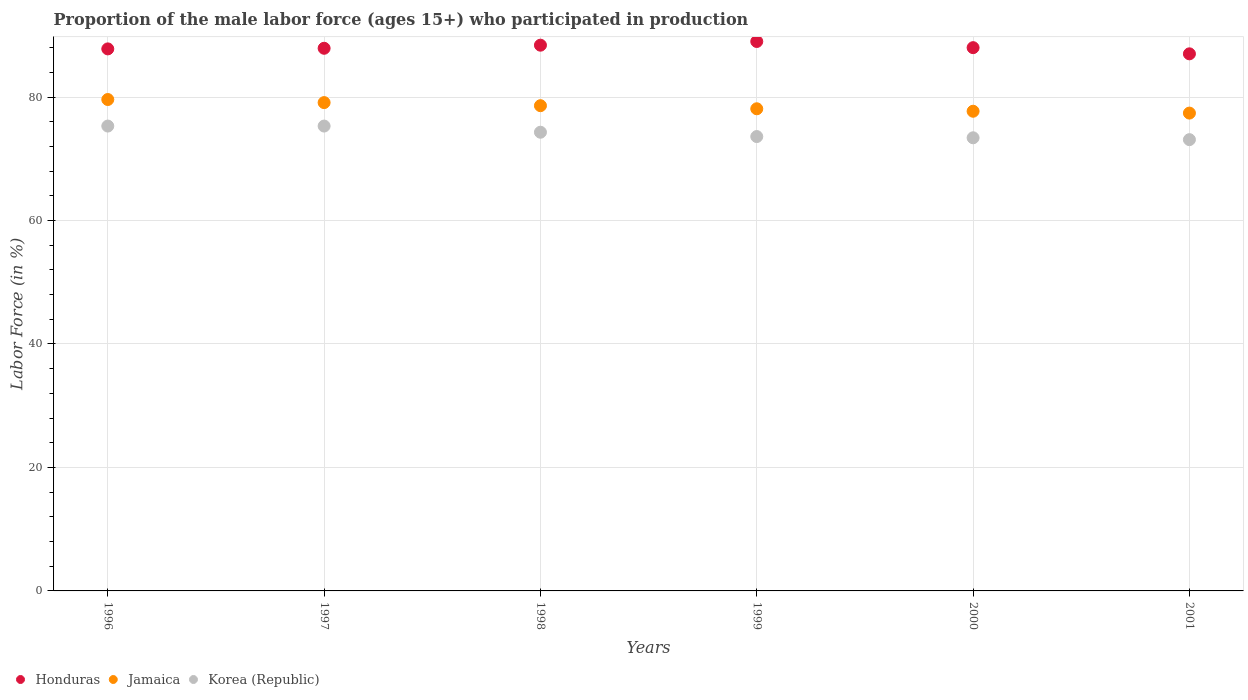How many different coloured dotlines are there?
Your response must be concise. 3. Is the number of dotlines equal to the number of legend labels?
Make the answer very short. Yes. What is the proportion of the male labor force who participated in production in Korea (Republic) in 1999?
Offer a very short reply. 73.6. Across all years, what is the maximum proportion of the male labor force who participated in production in Honduras?
Give a very brief answer. 89. Across all years, what is the minimum proportion of the male labor force who participated in production in Honduras?
Keep it short and to the point. 87. In which year was the proportion of the male labor force who participated in production in Honduras minimum?
Provide a short and direct response. 2001. What is the total proportion of the male labor force who participated in production in Honduras in the graph?
Offer a very short reply. 528.1. What is the difference between the proportion of the male labor force who participated in production in Jamaica in 1998 and that in 2000?
Your answer should be compact. 0.9. What is the difference between the proportion of the male labor force who participated in production in Korea (Republic) in 2001 and the proportion of the male labor force who participated in production in Honduras in 2000?
Your answer should be very brief. -14.9. What is the average proportion of the male labor force who participated in production in Korea (Republic) per year?
Provide a short and direct response. 74.17. In the year 2000, what is the difference between the proportion of the male labor force who participated in production in Jamaica and proportion of the male labor force who participated in production in Korea (Republic)?
Provide a short and direct response. 4.3. In how many years, is the proportion of the male labor force who participated in production in Jamaica greater than 16 %?
Offer a very short reply. 6. What is the ratio of the proportion of the male labor force who participated in production in Jamaica in 1998 to that in 1999?
Keep it short and to the point. 1.01. What is the difference between the highest and the second highest proportion of the male labor force who participated in production in Honduras?
Offer a very short reply. 0.6. What is the difference between the highest and the lowest proportion of the male labor force who participated in production in Jamaica?
Make the answer very short. 2.2. Is the sum of the proportion of the male labor force who participated in production in Honduras in 1997 and 2001 greater than the maximum proportion of the male labor force who participated in production in Korea (Republic) across all years?
Your response must be concise. Yes. Is it the case that in every year, the sum of the proportion of the male labor force who participated in production in Korea (Republic) and proportion of the male labor force who participated in production in Jamaica  is greater than the proportion of the male labor force who participated in production in Honduras?
Provide a short and direct response. Yes. Does the proportion of the male labor force who participated in production in Jamaica monotonically increase over the years?
Offer a very short reply. No. How many years are there in the graph?
Your answer should be very brief. 6. What is the difference between two consecutive major ticks on the Y-axis?
Provide a short and direct response. 20. Does the graph contain any zero values?
Ensure brevity in your answer.  No. Where does the legend appear in the graph?
Your response must be concise. Bottom left. How many legend labels are there?
Make the answer very short. 3. What is the title of the graph?
Your answer should be compact. Proportion of the male labor force (ages 15+) who participated in production. What is the label or title of the X-axis?
Offer a very short reply. Years. What is the label or title of the Y-axis?
Ensure brevity in your answer.  Labor Force (in %). What is the Labor Force (in %) of Honduras in 1996?
Give a very brief answer. 87.8. What is the Labor Force (in %) of Jamaica in 1996?
Ensure brevity in your answer.  79.6. What is the Labor Force (in %) of Korea (Republic) in 1996?
Keep it short and to the point. 75.3. What is the Labor Force (in %) in Honduras in 1997?
Ensure brevity in your answer.  87.9. What is the Labor Force (in %) of Jamaica in 1997?
Ensure brevity in your answer.  79.1. What is the Labor Force (in %) of Korea (Republic) in 1997?
Make the answer very short. 75.3. What is the Labor Force (in %) of Honduras in 1998?
Provide a succinct answer. 88.4. What is the Labor Force (in %) in Jamaica in 1998?
Your answer should be compact. 78.6. What is the Labor Force (in %) in Korea (Republic) in 1998?
Give a very brief answer. 74.3. What is the Labor Force (in %) in Honduras in 1999?
Your answer should be very brief. 89. What is the Labor Force (in %) of Jamaica in 1999?
Ensure brevity in your answer.  78.1. What is the Labor Force (in %) in Korea (Republic) in 1999?
Offer a terse response. 73.6. What is the Labor Force (in %) in Jamaica in 2000?
Provide a short and direct response. 77.7. What is the Labor Force (in %) in Korea (Republic) in 2000?
Your response must be concise. 73.4. What is the Labor Force (in %) of Jamaica in 2001?
Provide a short and direct response. 77.4. What is the Labor Force (in %) in Korea (Republic) in 2001?
Make the answer very short. 73.1. Across all years, what is the maximum Labor Force (in %) in Honduras?
Provide a short and direct response. 89. Across all years, what is the maximum Labor Force (in %) in Jamaica?
Offer a very short reply. 79.6. Across all years, what is the maximum Labor Force (in %) of Korea (Republic)?
Your answer should be very brief. 75.3. Across all years, what is the minimum Labor Force (in %) in Jamaica?
Offer a terse response. 77.4. Across all years, what is the minimum Labor Force (in %) in Korea (Republic)?
Offer a terse response. 73.1. What is the total Labor Force (in %) in Honduras in the graph?
Ensure brevity in your answer.  528.1. What is the total Labor Force (in %) in Jamaica in the graph?
Give a very brief answer. 470.5. What is the total Labor Force (in %) of Korea (Republic) in the graph?
Ensure brevity in your answer.  445. What is the difference between the Labor Force (in %) of Jamaica in 1996 and that in 1998?
Offer a terse response. 1. What is the difference between the Labor Force (in %) of Honduras in 1996 and that in 1999?
Your answer should be compact. -1.2. What is the difference between the Labor Force (in %) in Korea (Republic) in 1996 and that in 2001?
Provide a short and direct response. 2.2. What is the difference between the Labor Force (in %) of Honduras in 1997 and that in 1998?
Provide a succinct answer. -0.5. What is the difference between the Labor Force (in %) in Jamaica in 1997 and that in 1998?
Your response must be concise. 0.5. What is the difference between the Labor Force (in %) in Korea (Republic) in 1997 and that in 1998?
Your response must be concise. 1. What is the difference between the Labor Force (in %) of Jamaica in 1997 and that in 1999?
Ensure brevity in your answer.  1. What is the difference between the Labor Force (in %) of Korea (Republic) in 1997 and that in 1999?
Ensure brevity in your answer.  1.7. What is the difference between the Labor Force (in %) in Honduras in 1997 and that in 2000?
Your answer should be compact. -0.1. What is the difference between the Labor Force (in %) of Jamaica in 1997 and that in 2000?
Your answer should be compact. 1.4. What is the difference between the Labor Force (in %) of Korea (Republic) in 1997 and that in 2000?
Your answer should be compact. 1.9. What is the difference between the Labor Force (in %) of Korea (Republic) in 1997 and that in 2001?
Offer a terse response. 2.2. What is the difference between the Labor Force (in %) of Honduras in 1998 and that in 1999?
Provide a succinct answer. -0.6. What is the difference between the Labor Force (in %) in Korea (Republic) in 1998 and that in 2000?
Give a very brief answer. 0.9. What is the difference between the Labor Force (in %) in Honduras in 1998 and that in 2001?
Your answer should be very brief. 1.4. What is the difference between the Labor Force (in %) of Korea (Republic) in 1998 and that in 2001?
Your answer should be compact. 1.2. What is the difference between the Labor Force (in %) of Honduras in 1999 and that in 2000?
Provide a short and direct response. 1. What is the difference between the Labor Force (in %) of Jamaica in 1999 and that in 2000?
Make the answer very short. 0.4. What is the difference between the Labor Force (in %) of Honduras in 1999 and that in 2001?
Your response must be concise. 2. What is the difference between the Labor Force (in %) in Jamaica in 1999 and that in 2001?
Give a very brief answer. 0.7. What is the difference between the Labor Force (in %) of Korea (Republic) in 1999 and that in 2001?
Provide a short and direct response. 0.5. What is the difference between the Labor Force (in %) in Honduras in 2000 and that in 2001?
Your response must be concise. 1. What is the difference between the Labor Force (in %) in Jamaica in 2000 and that in 2001?
Your answer should be compact. 0.3. What is the difference between the Labor Force (in %) of Korea (Republic) in 2000 and that in 2001?
Keep it short and to the point. 0.3. What is the difference between the Labor Force (in %) in Jamaica in 1996 and the Labor Force (in %) in Korea (Republic) in 1997?
Your response must be concise. 4.3. What is the difference between the Labor Force (in %) of Jamaica in 1996 and the Labor Force (in %) of Korea (Republic) in 1998?
Provide a succinct answer. 5.3. What is the difference between the Labor Force (in %) in Honduras in 1996 and the Labor Force (in %) in Jamaica in 2000?
Keep it short and to the point. 10.1. What is the difference between the Labor Force (in %) of Jamaica in 1996 and the Labor Force (in %) of Korea (Republic) in 2000?
Offer a very short reply. 6.2. What is the difference between the Labor Force (in %) in Honduras in 1997 and the Labor Force (in %) in Jamaica in 1999?
Your answer should be compact. 9.8. What is the difference between the Labor Force (in %) of Jamaica in 1997 and the Labor Force (in %) of Korea (Republic) in 1999?
Your answer should be compact. 5.5. What is the difference between the Labor Force (in %) of Honduras in 1997 and the Labor Force (in %) of Korea (Republic) in 2000?
Offer a terse response. 14.5. What is the difference between the Labor Force (in %) of Jamaica in 1997 and the Labor Force (in %) of Korea (Republic) in 2001?
Offer a terse response. 6. What is the difference between the Labor Force (in %) of Honduras in 1998 and the Labor Force (in %) of Jamaica in 1999?
Your answer should be very brief. 10.3. What is the difference between the Labor Force (in %) in Honduras in 1998 and the Labor Force (in %) in Korea (Republic) in 1999?
Ensure brevity in your answer.  14.8. What is the difference between the Labor Force (in %) of Jamaica in 1998 and the Labor Force (in %) of Korea (Republic) in 1999?
Your answer should be compact. 5. What is the difference between the Labor Force (in %) in Honduras in 1998 and the Labor Force (in %) in Jamaica in 2000?
Your answer should be compact. 10.7. What is the difference between the Labor Force (in %) of Honduras in 1999 and the Labor Force (in %) of Jamaica in 2001?
Give a very brief answer. 11.6. What is the difference between the Labor Force (in %) in Jamaica in 1999 and the Labor Force (in %) in Korea (Republic) in 2001?
Your answer should be very brief. 5. What is the difference between the Labor Force (in %) in Honduras in 2000 and the Labor Force (in %) in Jamaica in 2001?
Offer a terse response. 10.6. What is the difference between the Labor Force (in %) of Honduras in 2000 and the Labor Force (in %) of Korea (Republic) in 2001?
Offer a very short reply. 14.9. What is the difference between the Labor Force (in %) of Jamaica in 2000 and the Labor Force (in %) of Korea (Republic) in 2001?
Offer a terse response. 4.6. What is the average Labor Force (in %) of Honduras per year?
Provide a short and direct response. 88.02. What is the average Labor Force (in %) in Jamaica per year?
Provide a succinct answer. 78.42. What is the average Labor Force (in %) of Korea (Republic) per year?
Give a very brief answer. 74.17. In the year 1996, what is the difference between the Labor Force (in %) of Honduras and Labor Force (in %) of Jamaica?
Give a very brief answer. 8.2. In the year 1996, what is the difference between the Labor Force (in %) in Honduras and Labor Force (in %) in Korea (Republic)?
Ensure brevity in your answer.  12.5. In the year 1997, what is the difference between the Labor Force (in %) in Honduras and Labor Force (in %) in Jamaica?
Provide a succinct answer. 8.8. In the year 1997, what is the difference between the Labor Force (in %) of Honduras and Labor Force (in %) of Korea (Republic)?
Offer a very short reply. 12.6. In the year 1997, what is the difference between the Labor Force (in %) of Jamaica and Labor Force (in %) of Korea (Republic)?
Give a very brief answer. 3.8. In the year 1998, what is the difference between the Labor Force (in %) in Jamaica and Labor Force (in %) in Korea (Republic)?
Keep it short and to the point. 4.3. In the year 1999, what is the difference between the Labor Force (in %) in Honduras and Labor Force (in %) in Korea (Republic)?
Provide a short and direct response. 15.4. In the year 1999, what is the difference between the Labor Force (in %) of Jamaica and Labor Force (in %) of Korea (Republic)?
Keep it short and to the point. 4.5. In the year 2000, what is the difference between the Labor Force (in %) in Honduras and Labor Force (in %) in Korea (Republic)?
Ensure brevity in your answer.  14.6. In the year 2001, what is the difference between the Labor Force (in %) of Honduras and Labor Force (in %) of Korea (Republic)?
Your response must be concise. 13.9. What is the ratio of the Labor Force (in %) in Jamaica in 1996 to that in 1997?
Provide a succinct answer. 1.01. What is the ratio of the Labor Force (in %) of Jamaica in 1996 to that in 1998?
Your answer should be compact. 1.01. What is the ratio of the Labor Force (in %) of Korea (Republic) in 1996 to that in 1998?
Give a very brief answer. 1.01. What is the ratio of the Labor Force (in %) of Honduras in 1996 to that in 1999?
Your response must be concise. 0.99. What is the ratio of the Labor Force (in %) of Jamaica in 1996 to that in 1999?
Give a very brief answer. 1.02. What is the ratio of the Labor Force (in %) of Korea (Republic) in 1996 to that in 1999?
Offer a terse response. 1.02. What is the ratio of the Labor Force (in %) in Jamaica in 1996 to that in 2000?
Keep it short and to the point. 1.02. What is the ratio of the Labor Force (in %) in Korea (Republic) in 1996 to that in 2000?
Provide a short and direct response. 1.03. What is the ratio of the Labor Force (in %) in Honduras in 1996 to that in 2001?
Make the answer very short. 1.01. What is the ratio of the Labor Force (in %) of Jamaica in 1996 to that in 2001?
Your answer should be compact. 1.03. What is the ratio of the Labor Force (in %) of Korea (Republic) in 1996 to that in 2001?
Your response must be concise. 1.03. What is the ratio of the Labor Force (in %) in Honduras in 1997 to that in 1998?
Keep it short and to the point. 0.99. What is the ratio of the Labor Force (in %) of Jamaica in 1997 to that in 1998?
Offer a terse response. 1.01. What is the ratio of the Labor Force (in %) in Korea (Republic) in 1997 to that in 1998?
Provide a succinct answer. 1.01. What is the ratio of the Labor Force (in %) in Honduras in 1997 to that in 1999?
Keep it short and to the point. 0.99. What is the ratio of the Labor Force (in %) in Jamaica in 1997 to that in 1999?
Provide a short and direct response. 1.01. What is the ratio of the Labor Force (in %) of Korea (Republic) in 1997 to that in 1999?
Provide a succinct answer. 1.02. What is the ratio of the Labor Force (in %) of Korea (Republic) in 1997 to that in 2000?
Provide a short and direct response. 1.03. What is the ratio of the Labor Force (in %) in Honduras in 1997 to that in 2001?
Your answer should be very brief. 1.01. What is the ratio of the Labor Force (in %) in Korea (Republic) in 1997 to that in 2001?
Keep it short and to the point. 1.03. What is the ratio of the Labor Force (in %) in Honduras in 1998 to that in 1999?
Your answer should be very brief. 0.99. What is the ratio of the Labor Force (in %) in Jamaica in 1998 to that in 1999?
Give a very brief answer. 1.01. What is the ratio of the Labor Force (in %) in Korea (Republic) in 1998 to that in 1999?
Give a very brief answer. 1.01. What is the ratio of the Labor Force (in %) of Jamaica in 1998 to that in 2000?
Keep it short and to the point. 1.01. What is the ratio of the Labor Force (in %) of Korea (Republic) in 1998 to that in 2000?
Make the answer very short. 1.01. What is the ratio of the Labor Force (in %) in Honduras in 1998 to that in 2001?
Offer a very short reply. 1.02. What is the ratio of the Labor Force (in %) of Jamaica in 1998 to that in 2001?
Provide a succinct answer. 1.02. What is the ratio of the Labor Force (in %) in Korea (Republic) in 1998 to that in 2001?
Give a very brief answer. 1.02. What is the ratio of the Labor Force (in %) in Honduras in 1999 to that in 2000?
Your response must be concise. 1.01. What is the ratio of the Labor Force (in %) in Jamaica in 1999 to that in 2000?
Give a very brief answer. 1.01. What is the ratio of the Labor Force (in %) of Korea (Republic) in 1999 to that in 2000?
Provide a short and direct response. 1. What is the ratio of the Labor Force (in %) of Honduras in 1999 to that in 2001?
Make the answer very short. 1.02. What is the ratio of the Labor Force (in %) of Korea (Republic) in 1999 to that in 2001?
Provide a short and direct response. 1.01. What is the ratio of the Labor Force (in %) in Honduras in 2000 to that in 2001?
Provide a short and direct response. 1.01. What is the ratio of the Labor Force (in %) in Korea (Republic) in 2000 to that in 2001?
Your answer should be very brief. 1. What is the difference between the highest and the second highest Labor Force (in %) in Honduras?
Keep it short and to the point. 0.6. What is the difference between the highest and the lowest Labor Force (in %) of Korea (Republic)?
Offer a very short reply. 2.2. 